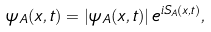<formula> <loc_0><loc_0><loc_500><loc_500>\psi _ { A } ( x , t ) = \left | \psi _ { A } ( x , t ) \right | e ^ { i S _ { A } ( x , t ) } ,</formula> 